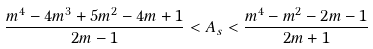Convert formula to latex. <formula><loc_0><loc_0><loc_500><loc_500>\frac { m ^ { 4 } - 4 m ^ { 3 } + 5 m ^ { 2 } - 4 m + 1 } { 2 m - 1 } < A _ { s } < \frac { m ^ { 4 } - m ^ { 2 } - 2 m - 1 } { 2 m + 1 }</formula> 